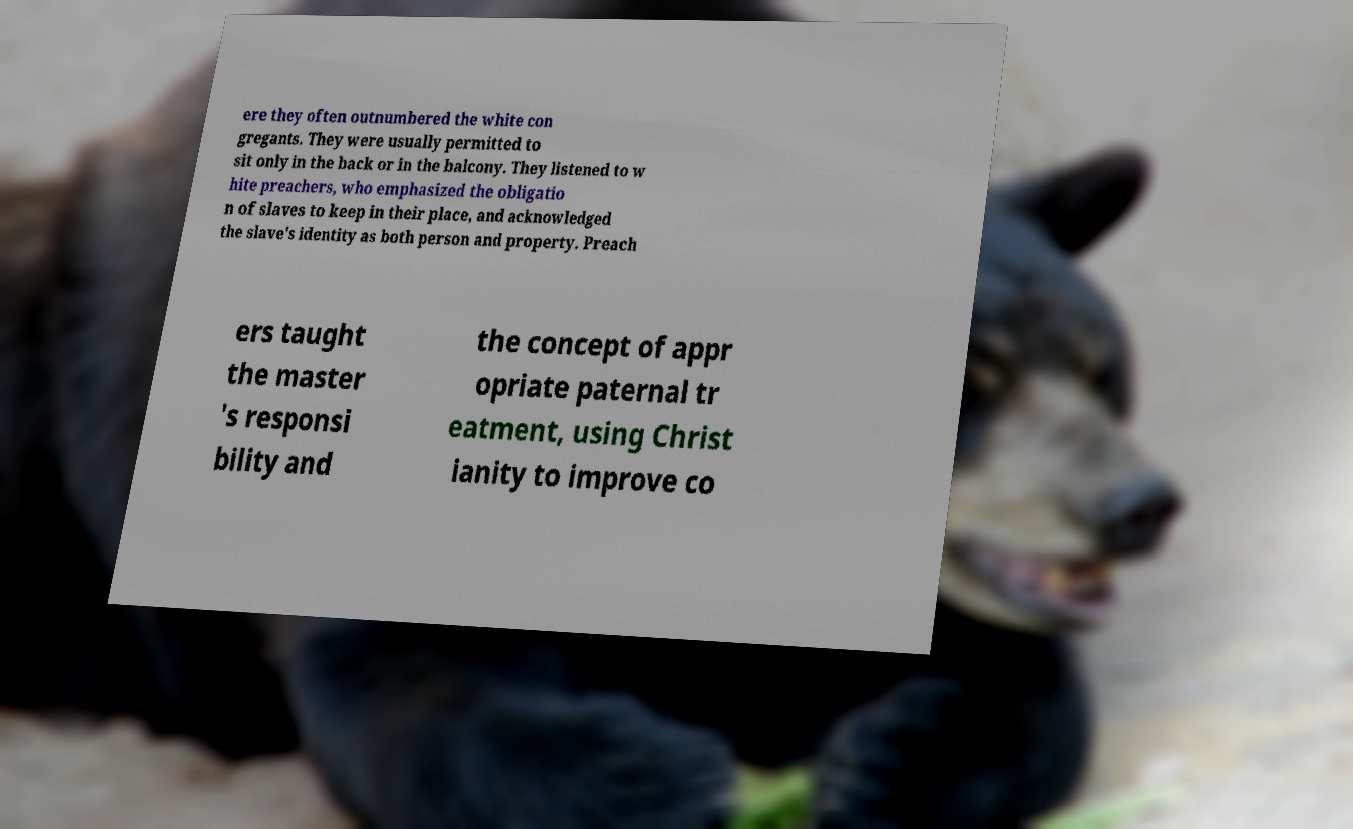Please identify and transcribe the text found in this image. ere they often outnumbered the white con gregants. They were usually permitted to sit only in the back or in the balcony. They listened to w hite preachers, who emphasized the obligatio n of slaves to keep in their place, and acknowledged the slave's identity as both person and property. Preach ers taught the master 's responsi bility and the concept of appr opriate paternal tr eatment, using Christ ianity to improve co 